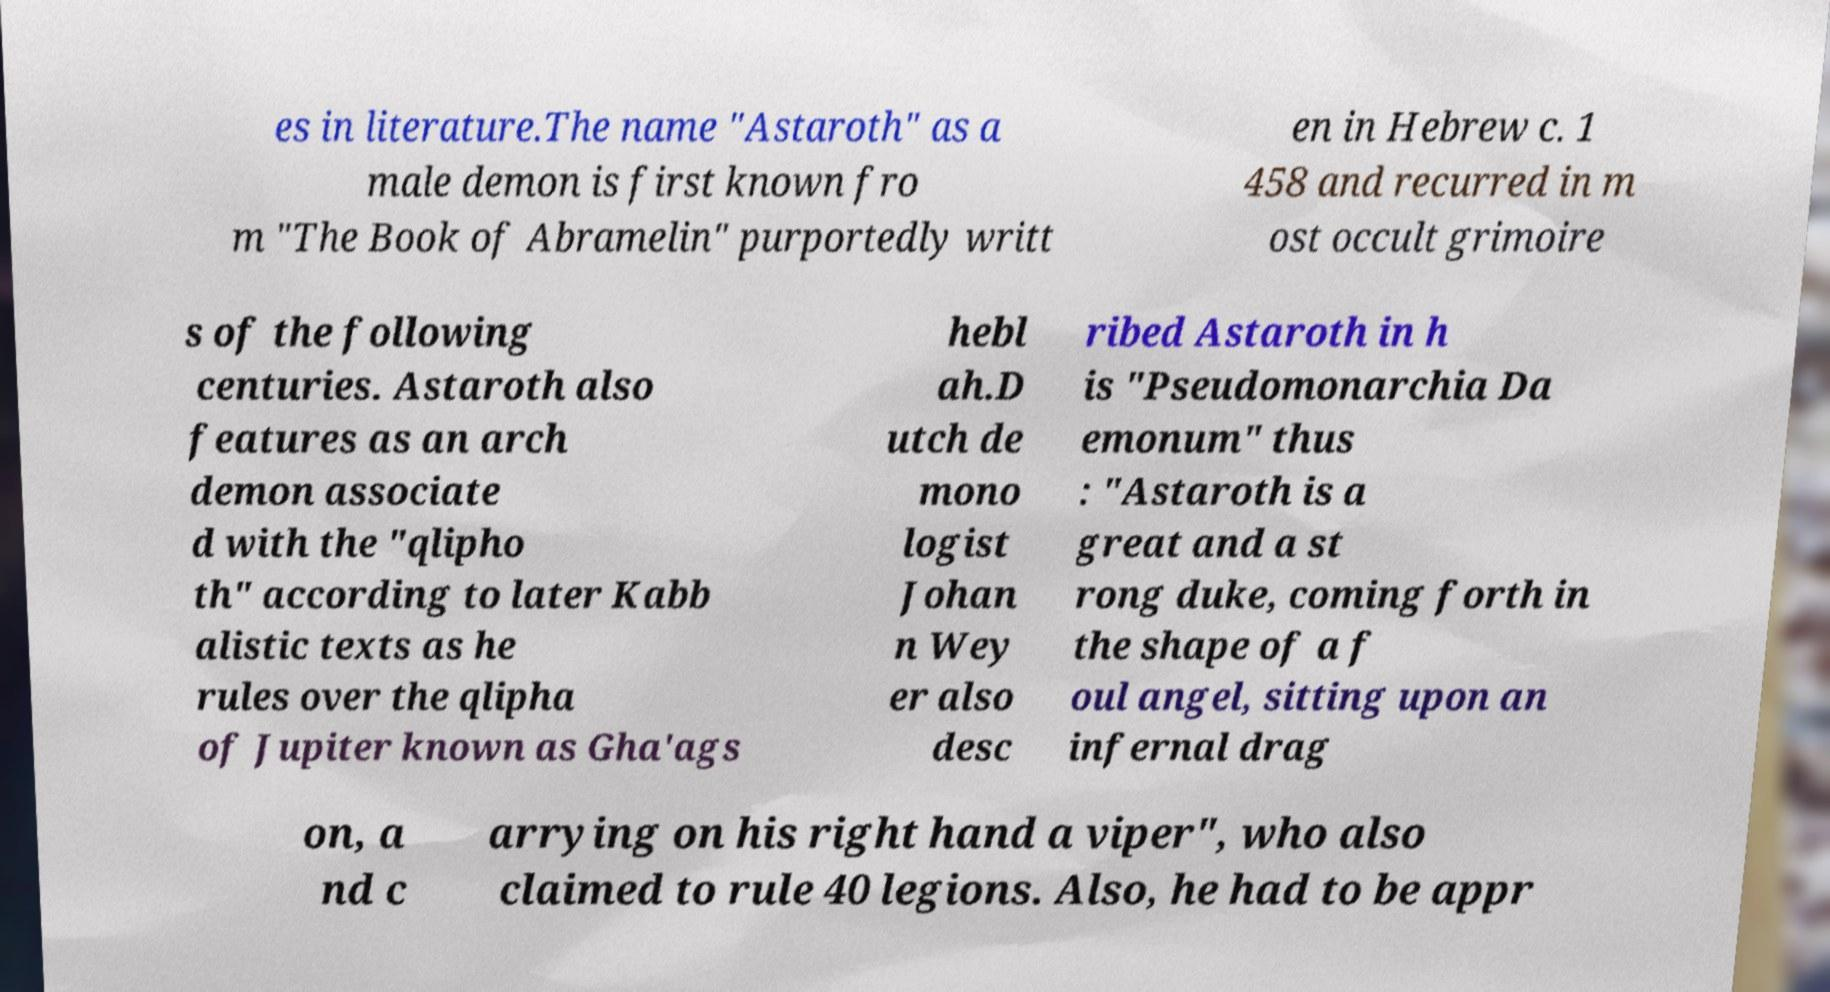Please read and relay the text visible in this image. What does it say? es in literature.The name "Astaroth" as a male demon is first known fro m "The Book of Abramelin" purportedly writt en in Hebrew c. 1 458 and recurred in m ost occult grimoire s of the following centuries. Astaroth also features as an arch demon associate d with the "qlipho th" according to later Kabb alistic texts as he rules over the qlipha of Jupiter known as Gha'ags hebl ah.D utch de mono logist Johan n Wey er also desc ribed Astaroth in h is "Pseudomonarchia Da emonum" thus : "Astaroth is a great and a st rong duke, coming forth in the shape of a f oul angel, sitting upon an infernal drag on, a nd c arrying on his right hand a viper", who also claimed to rule 40 legions. Also, he had to be appr 